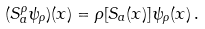<formula> <loc_0><loc_0><loc_500><loc_500>( S _ { a } ^ { \rho } \psi _ { \rho } ) ( x ) = \rho [ S _ { a } ( x ) ] \psi _ { \rho } ( x ) \, .</formula> 